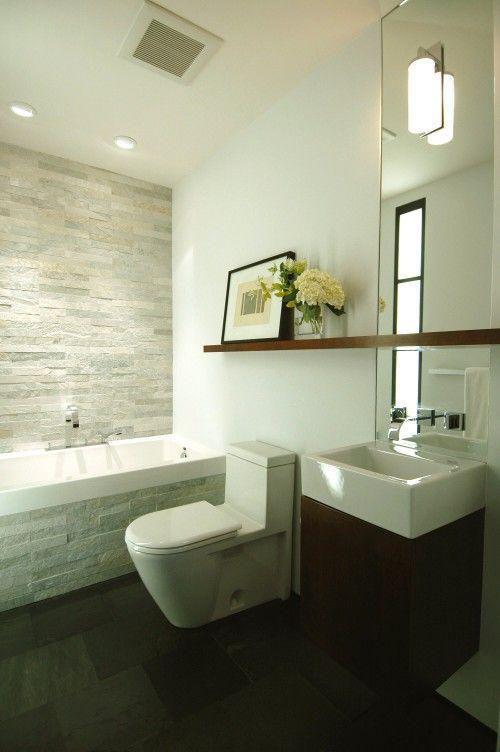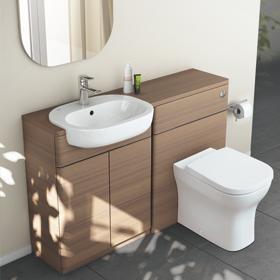The first image is the image on the left, the second image is the image on the right. For the images shown, is this caption "One image features a bathtub, and the other shows a vessel sink atop a counter with an open space and shelf beneath it." true? Answer yes or no. No. The first image is the image on the left, the second image is the image on the right. Given the left and right images, does the statement "One of the images contains a soft bath mat on the floor." hold true? Answer yes or no. No. 